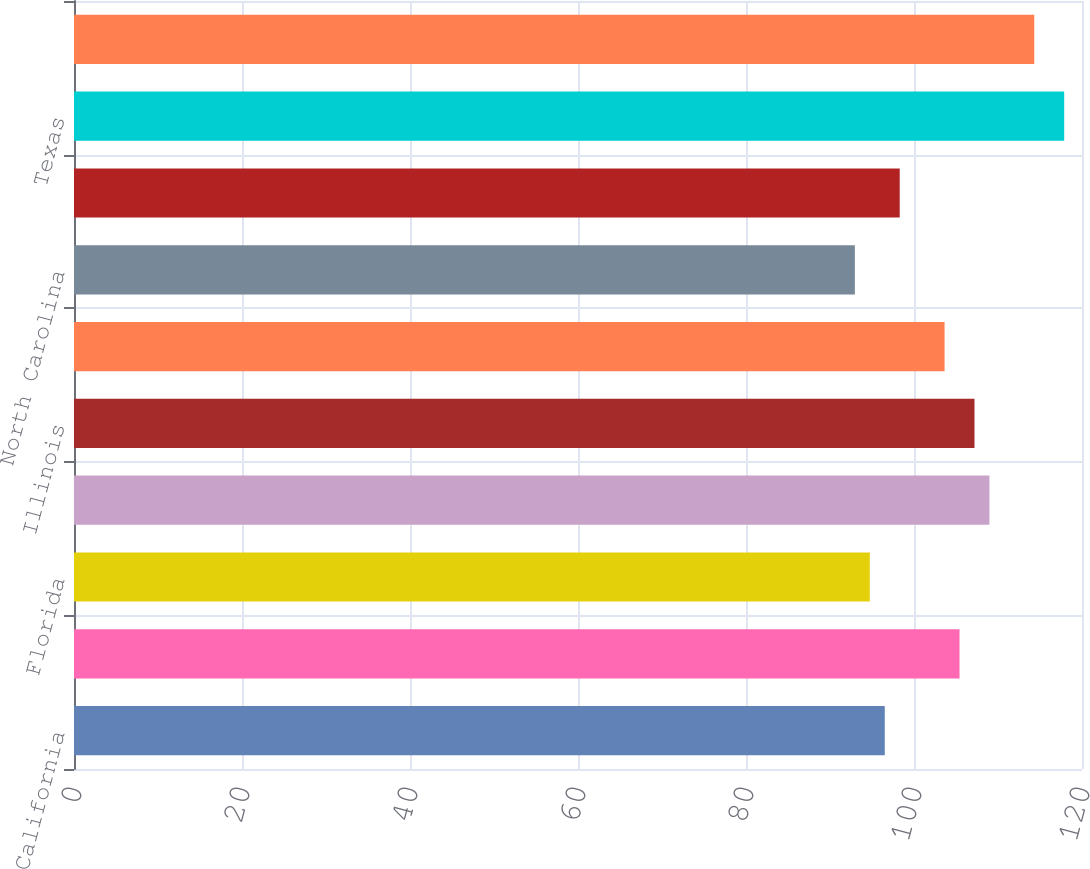Convert chart to OTSL. <chart><loc_0><loc_0><loc_500><loc_500><bar_chart><fcel>California<fcel>Virginia<fcel>Florida<fcel>Maryland<fcel>Illinois<fcel>Georgia<fcel>North Carolina<fcel>Colorado<fcel>Texas<fcel>Pennsylvania<nl><fcel>96.52<fcel>105.42<fcel>94.74<fcel>108.98<fcel>107.2<fcel>103.64<fcel>92.96<fcel>98.3<fcel>117.88<fcel>114.32<nl></chart> 